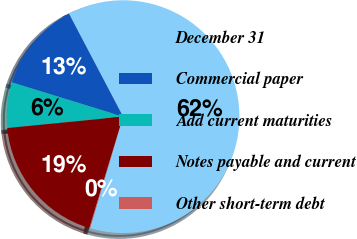<chart> <loc_0><loc_0><loc_500><loc_500><pie_chart><fcel>December 31<fcel>Commercial paper<fcel>Add current maturities<fcel>Notes payable and current<fcel>Other short-term debt<nl><fcel>62.28%<fcel>12.54%<fcel>6.32%<fcel>18.76%<fcel>0.11%<nl></chart> 